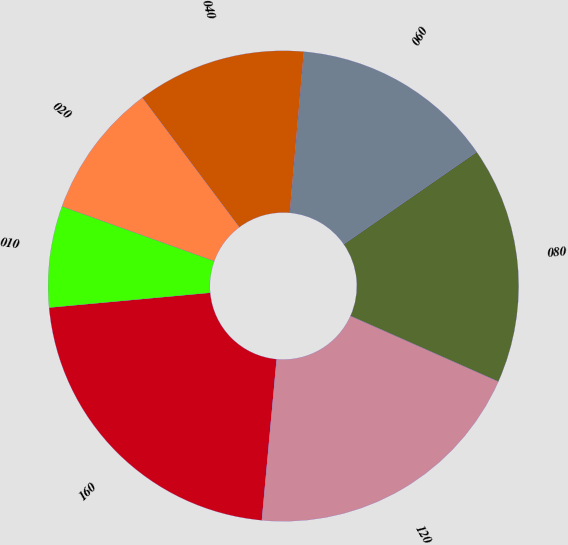Convert chart to OTSL. <chart><loc_0><loc_0><loc_500><loc_500><pie_chart><fcel>160<fcel>120<fcel>080<fcel>060<fcel>040<fcel>020<fcel>010<nl><fcel>22.08%<fcel>19.81%<fcel>16.3%<fcel>13.96%<fcel>11.62%<fcel>9.28%<fcel>6.95%<nl></chart> 